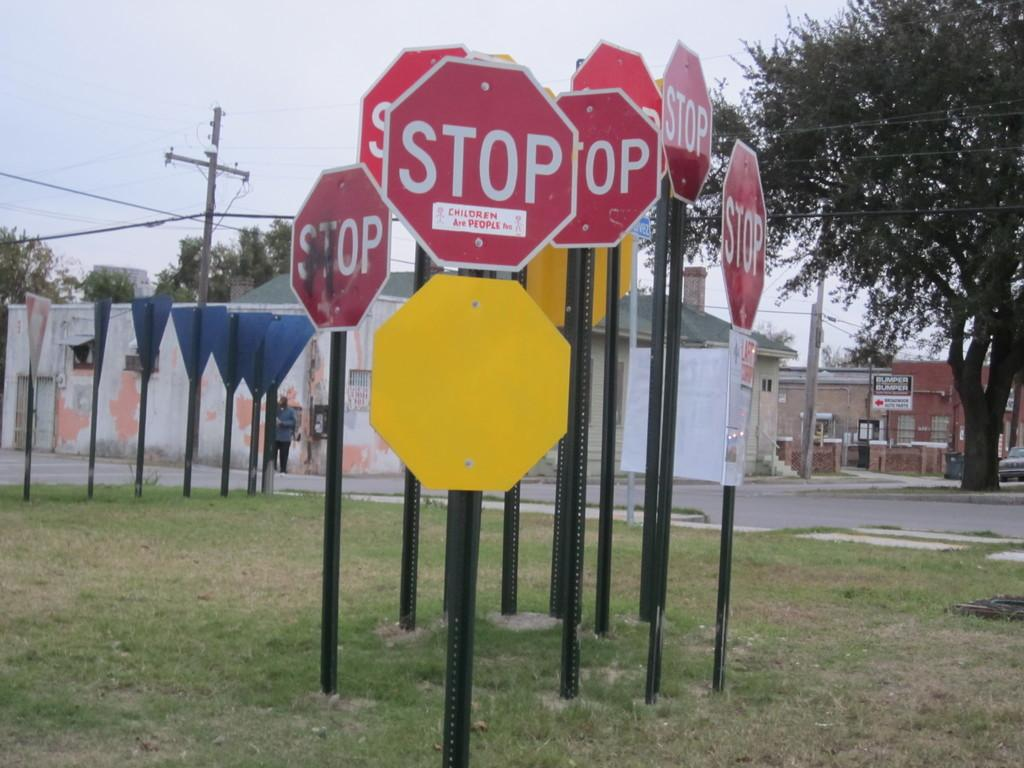<image>
Share a concise interpretation of the image provided. Several stop signs are grouped together, with one branded with a sticker reading "children are people." 